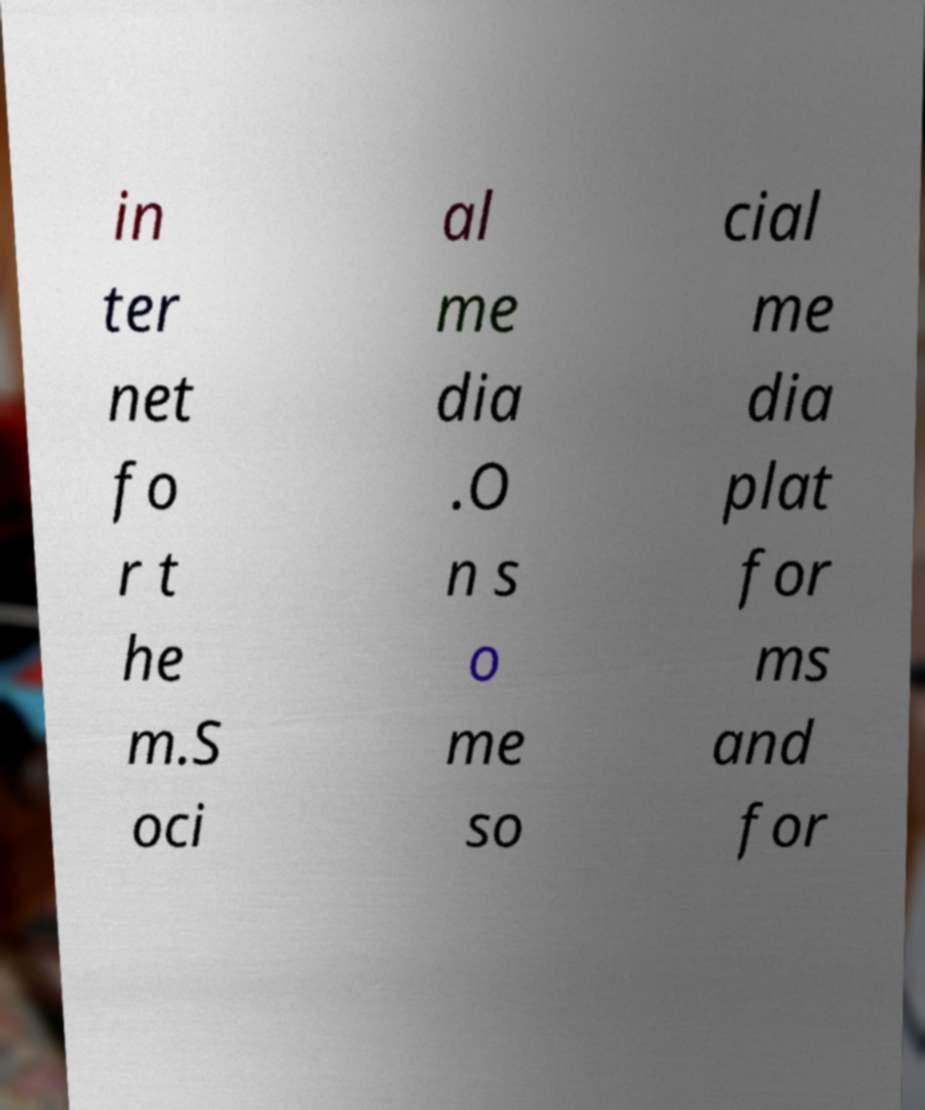Could you extract and type out the text from this image? in ter net fo r t he m.S oci al me dia .O n s o me so cial me dia plat for ms and for 